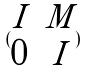<formula> <loc_0><loc_0><loc_500><loc_500>( \begin{matrix} I & M \\ 0 & I \end{matrix} )</formula> 